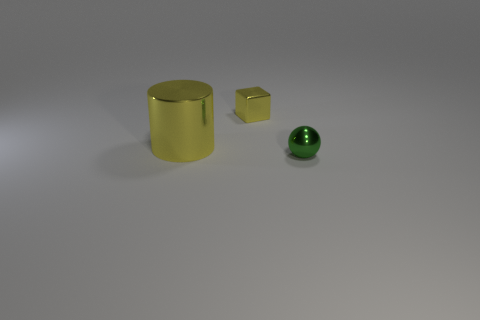Is there any other thing that has the same size as the cylinder?
Provide a short and direct response. No. What is the shape of the big shiny thing?
Your response must be concise. Cylinder. The tiny metallic thing to the left of the small object that is to the right of the yellow metal thing that is right of the large yellow object is what color?
Offer a very short reply. Yellow. There is a metallic block that is the same size as the green shiny ball; what color is it?
Offer a very short reply. Yellow. How many rubber things are either small green balls or yellow cylinders?
Offer a terse response. 0. The small sphere that is the same material as the yellow block is what color?
Your answer should be very brief. Green. What material is the tiny thing that is right of the tiny metallic thing behind the small green sphere?
Provide a short and direct response. Metal. What number of things are either objects behind the ball or metal things that are in front of the big cylinder?
Ensure brevity in your answer.  3. There is a thing that is behind the thing that is to the left of the small shiny thing that is behind the green shiny thing; what size is it?
Ensure brevity in your answer.  Small. Is the number of green objects that are to the left of the cylinder the same as the number of big cyan matte cylinders?
Provide a succinct answer. Yes. 